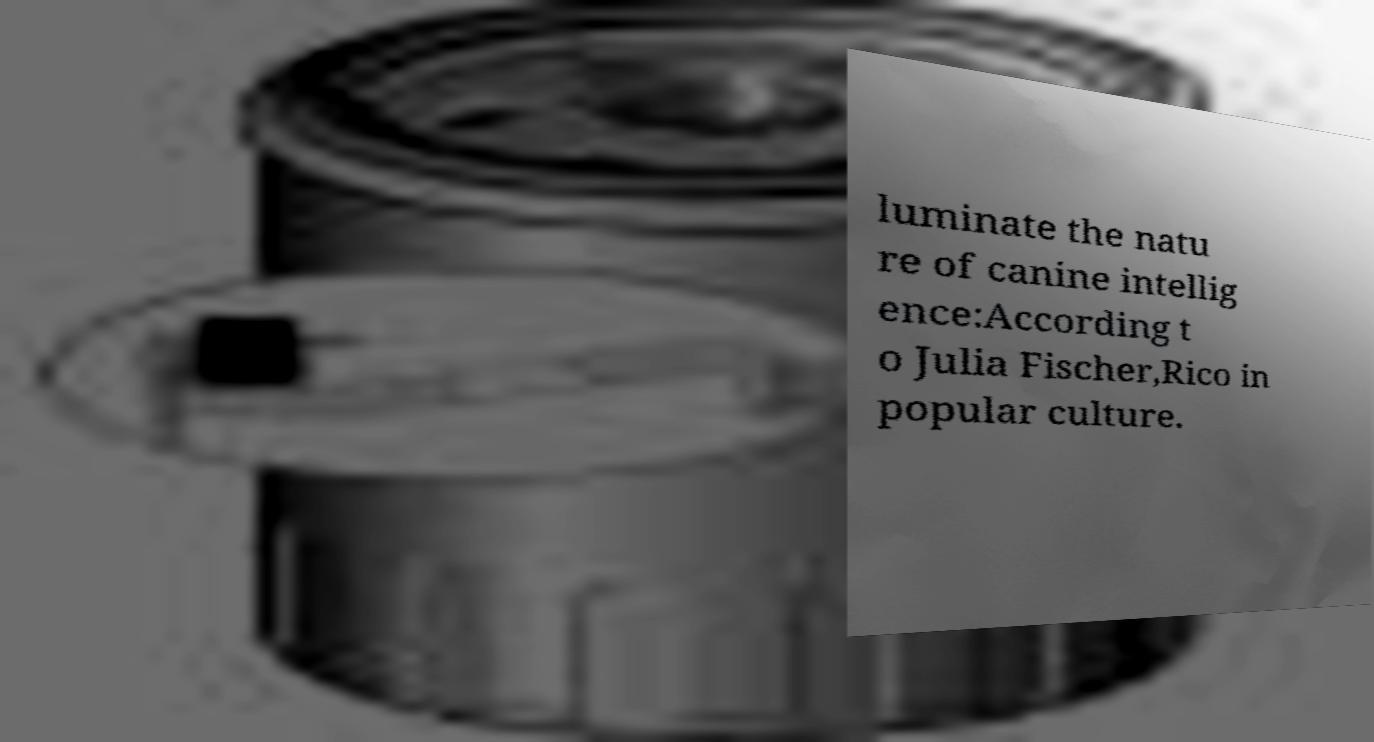Can you read and provide the text displayed in the image?This photo seems to have some interesting text. Can you extract and type it out for me? luminate the natu re of canine intellig ence:According t o Julia Fischer,Rico in popular culture. 